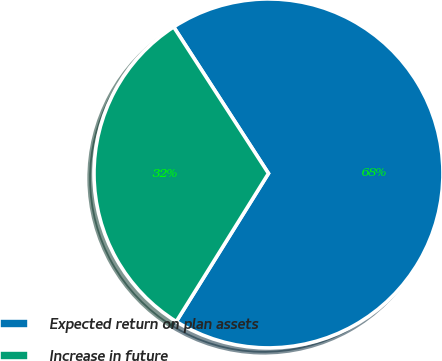<chart> <loc_0><loc_0><loc_500><loc_500><pie_chart><fcel>Expected return on plan assets<fcel>Increase in future<nl><fcel>68.0%<fcel>32.0%<nl></chart> 